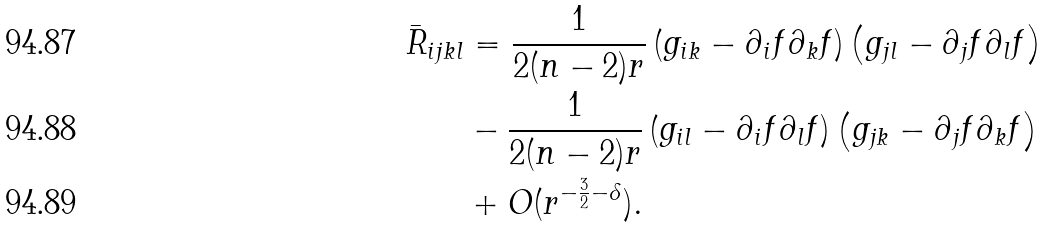Convert formula to latex. <formula><loc_0><loc_0><loc_500><loc_500>\bar { R } _ { i j k l } & = \frac { 1 } { 2 ( n - 2 ) r } \left ( g _ { i k } - \partial _ { i } f \partial _ { k } f \right ) \left ( g _ { j l } - \partial _ { j } f \partial _ { l } f \right ) \\ & - \frac { 1 } { 2 ( n - 2 ) r } \left ( g _ { i l } - \partial _ { i } f \partial _ { l } f \right ) \left ( g _ { j k } - \partial _ { j } f \partial _ { k } f \right ) \\ & + O ( r ^ { - \frac { 3 } { 2 } - \delta } ) .</formula> 